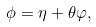<formula> <loc_0><loc_0><loc_500><loc_500>\phi = \eta + { \theta } \varphi ,</formula> 